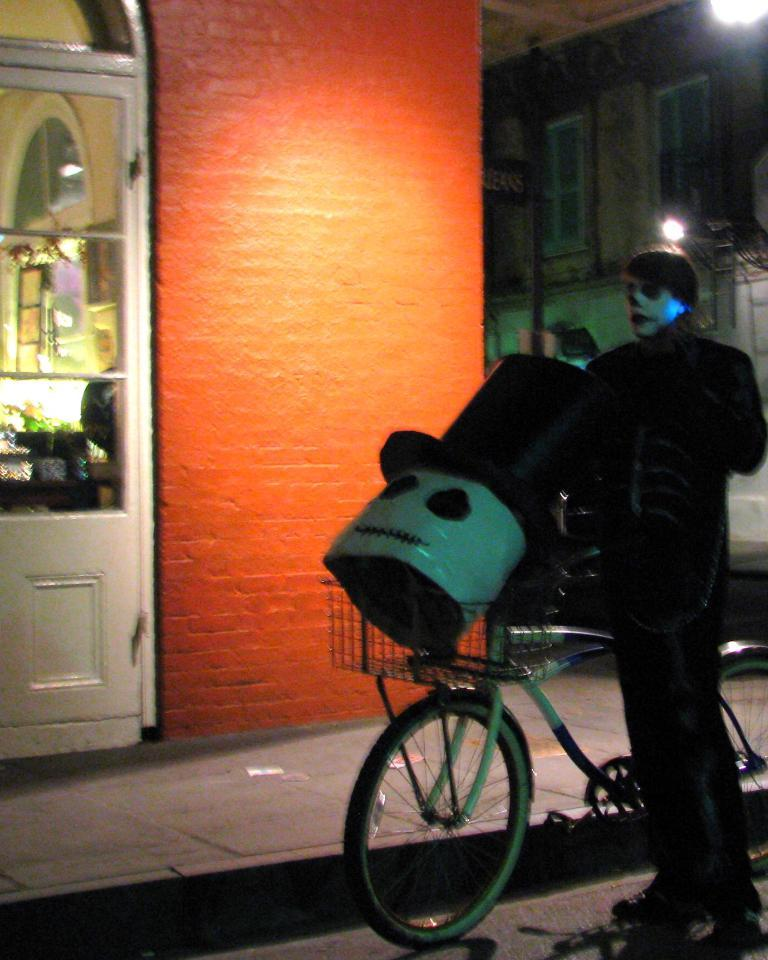What is the main subject of the image? There is a person in the image. What is the person wearing? The person is wearing clothes. What is the person doing in the image? The person is standing with a cycle. What can be seen in the middle of the image? There is a wall in the middle of the image. What is the source of light in the image? There is a light in the top right of the image. What type of pear is being painted on the canvas in the image? There is no pear or canvas present in the image. What color is the person's lipstick in the image? There is no lipstick or indication of the person's lips in the image. 